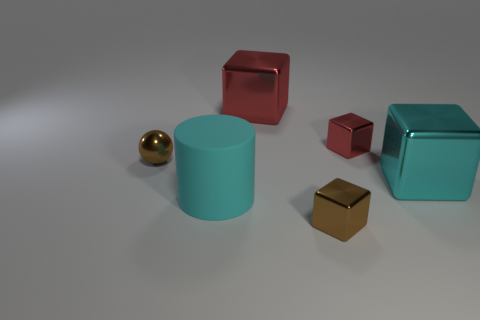What color is the other large metal object that is the same shape as the large red metal object?
Keep it short and to the point. Cyan. Are there any brown shiny things that have the same shape as the small red thing?
Your answer should be very brief. Yes. Are there fewer big cyan shiny blocks than large blocks?
Your response must be concise. Yes. Is the cyan rubber object the same shape as the small red object?
Provide a short and direct response. No. How many things are either tiny cyan rubber things or small metallic things left of the cylinder?
Provide a succinct answer. 1. What number of yellow matte spheres are there?
Make the answer very short. 0. Are there any matte cylinders that have the same size as the shiny sphere?
Keep it short and to the point. No. Is the number of tiny spheres left of the big cyan shiny object less than the number of cylinders?
Keep it short and to the point. No. Is the size of the shiny ball the same as the brown shiny cube?
Your answer should be very brief. Yes. There is a brown block that is the same material as the tiny brown sphere; what size is it?
Provide a short and direct response. Small. 